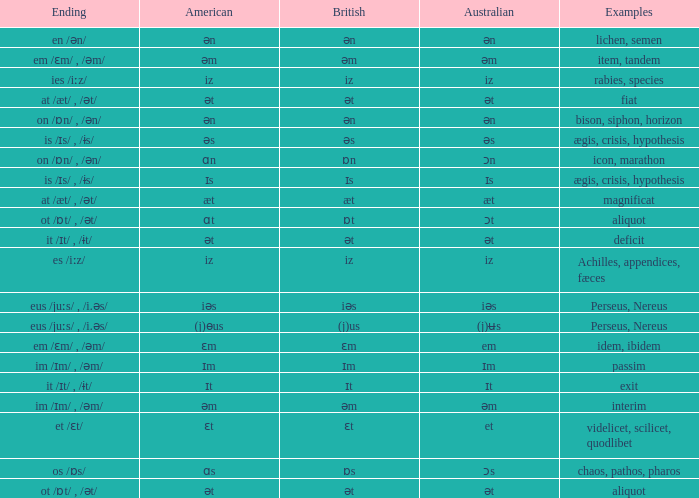Which Examples has Australian of əm? Item, tandem, interim. 